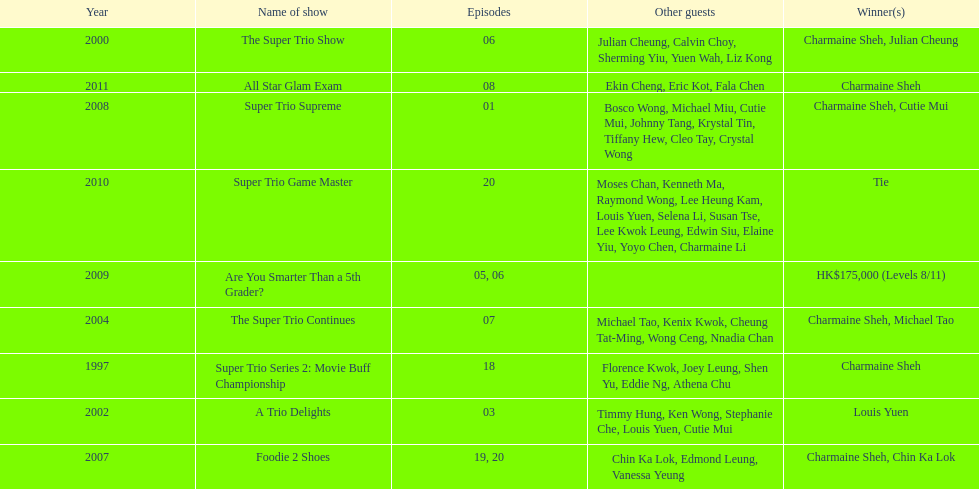In the 2002 show "a trio delights," what was the count of other attendees? 5. 